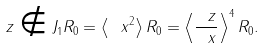<formula> <loc_0><loc_0><loc_500><loc_500>\ z \notin J _ { 1 } R _ { 0 } = \left \langle \ x ^ { 2 } \right \rangle R _ { 0 } = \left \langle \frac { \ z } { \ x } \right \rangle ^ { 4 } R _ { 0 } .</formula> 